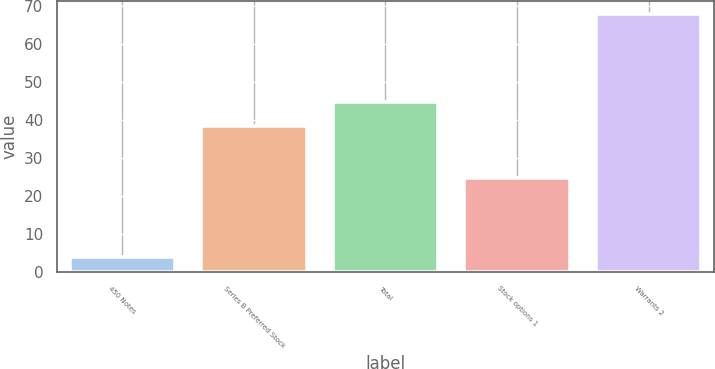<chart> <loc_0><loc_0><loc_500><loc_500><bar_chart><fcel>450 Notes<fcel>Series B Preferred Stock<fcel>Total<fcel>Stock options 1<fcel>Warrants 2<nl><fcel>3.9<fcel>38.4<fcel>44.8<fcel>24.7<fcel>67.9<nl></chart> 